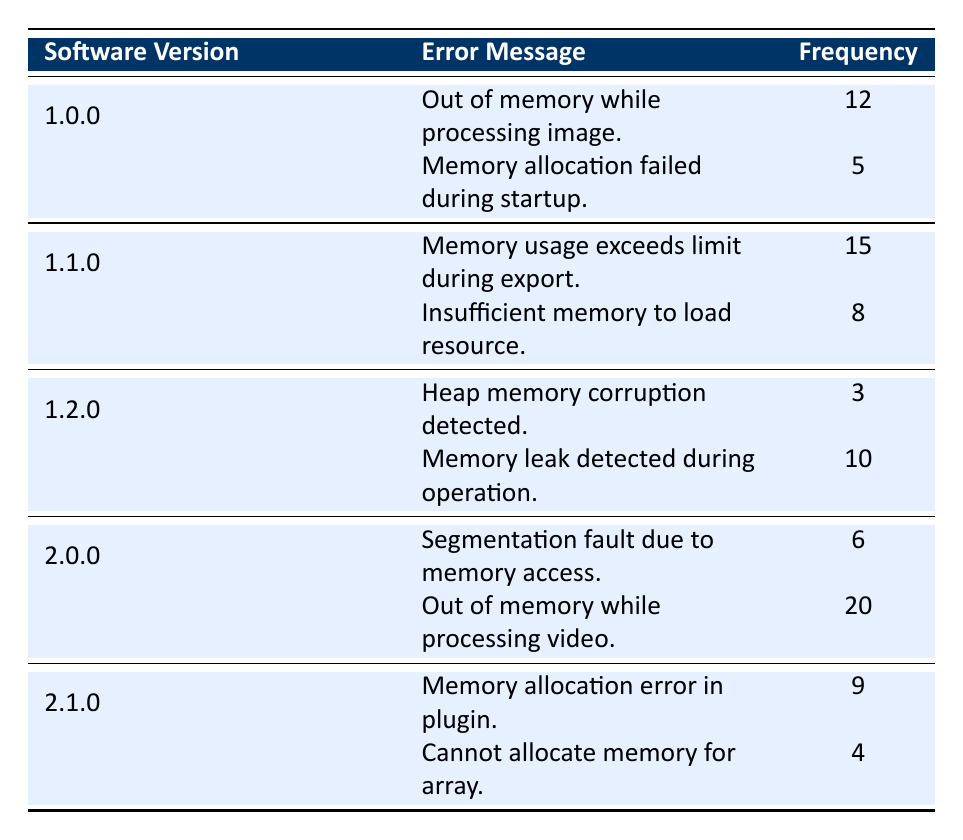What is the frequency of the error message "Out of memory while processing image." in version 1.0.0? The table directly shows that the error message "Out of memory while processing image." has a frequency of 12 in the software version 1.0.0.
Answer: 12 Which software version has the highest frequency of memory-related error messages? By examining the total frequencies for each software version, the highest frequency is 20 for version 2.0.0 (error message: "Out of memory while processing video."), which is the largest single count in the table.
Answer: 2.0.0 How many total memory-related errors were reported for version 1.2.0? The frequencies for version 1.2.0 are 3 (Heap memory corruption detected) and 10 (Memory leak detected during operation). Adding these gives 3 + 10 = 13.
Answer: 13 Is there an error message in version 2.1.0 with a frequency greater than 8? Checking the frequencies for version 2.1.0, the error message "Memory allocation error in plugin." has a frequency of 9, which is greater than 8. Hence the answer is yes.
Answer: Yes What is the combined frequency of memory-related error messages in software versions 1.0.0 and 1.1.0? The total frequency for version 1.0.0 is 12 + 5 = 17. For version 1.1.0, it's 15 + 8 = 23. Adding them gives 17 + 23 = 40.
Answer: 40 What is the frequency of the error message "Cannot allocate memory for array." and does it exceed 4? The table shows that the frequency of this error message is 4. Since 4 does not exceed 4, the answer is no.
Answer: No What is the average frequency of memory-related error messages for version 1.1.0? The frequencies for version 1.1.0 are 15 and 8. The sum is 15 + 8 = 23, and since there are 2 messages, the average is 23 / 2 = 11.5.
Answer: 11.5 In which software version is the error message "Memory leak detected during operation." found, and what is its frequency? The message "Memory leak detected during operation." is found in version 1.2.0 with a frequency of 10.
Answer: 1.2.0, 10 How many error messages had a frequency greater than 10 across all versions? Checking the table, the frequencies greater than 10 are 12 (1.0.0), 15 (1.1.0), 20 (2.0.0), and 10 (1.2.0). Thus, we have three messages in total: 12, 15, and 20.
Answer: 3 